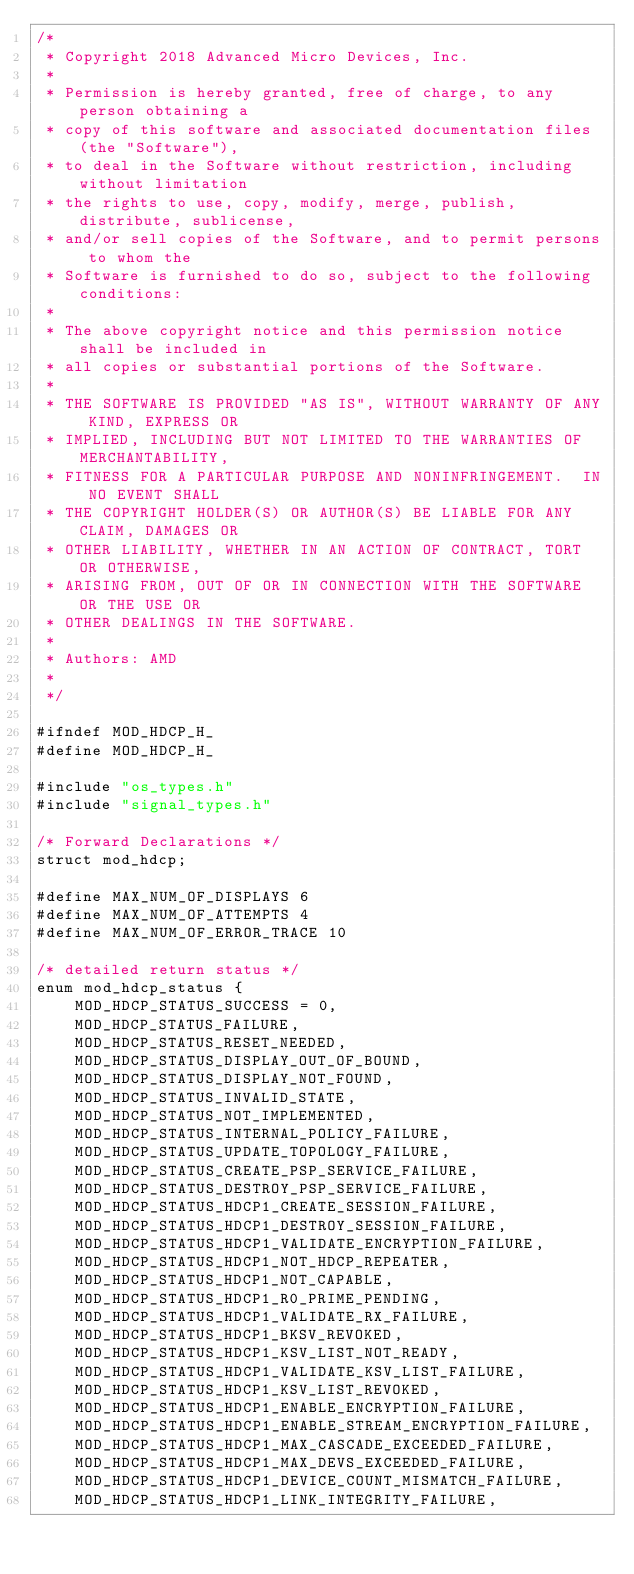Convert code to text. <code><loc_0><loc_0><loc_500><loc_500><_C_>/*
 * Copyright 2018 Advanced Micro Devices, Inc.
 *
 * Permission is hereby granted, free of charge, to any person obtaining a
 * copy of this software and associated documentation files (the "Software"),
 * to deal in the Software without restriction, including without limitation
 * the rights to use, copy, modify, merge, publish, distribute, sublicense,
 * and/or sell copies of the Software, and to permit persons to whom the
 * Software is furnished to do so, subject to the following conditions:
 *
 * The above copyright notice and this permission notice shall be included in
 * all copies or substantial portions of the Software.
 *
 * THE SOFTWARE IS PROVIDED "AS IS", WITHOUT WARRANTY OF ANY KIND, EXPRESS OR
 * IMPLIED, INCLUDING BUT NOT LIMITED TO THE WARRANTIES OF MERCHANTABILITY,
 * FITNESS FOR A PARTICULAR PURPOSE AND NONINFRINGEMENT.  IN NO EVENT SHALL
 * THE COPYRIGHT HOLDER(S) OR AUTHOR(S) BE LIABLE FOR ANY CLAIM, DAMAGES OR
 * OTHER LIABILITY, WHETHER IN AN ACTION OF CONTRACT, TORT OR OTHERWISE,
 * ARISING FROM, OUT OF OR IN CONNECTION WITH THE SOFTWARE OR THE USE OR
 * OTHER DEALINGS IN THE SOFTWARE.
 *
 * Authors: AMD
 *
 */

#ifndef MOD_HDCP_H_
#define MOD_HDCP_H_

#include "os_types.h"
#include "signal_types.h"

/* Forward Declarations */
struct mod_hdcp;

#define MAX_NUM_OF_DISPLAYS 6
#define MAX_NUM_OF_ATTEMPTS 4
#define MAX_NUM_OF_ERROR_TRACE 10

/* detailed return status */
enum mod_hdcp_status {
	MOD_HDCP_STATUS_SUCCESS = 0,
	MOD_HDCP_STATUS_FAILURE,
	MOD_HDCP_STATUS_RESET_NEEDED,
	MOD_HDCP_STATUS_DISPLAY_OUT_OF_BOUND,
	MOD_HDCP_STATUS_DISPLAY_NOT_FOUND,
	MOD_HDCP_STATUS_INVALID_STATE,
	MOD_HDCP_STATUS_NOT_IMPLEMENTED,
	MOD_HDCP_STATUS_INTERNAL_POLICY_FAILURE,
	MOD_HDCP_STATUS_UPDATE_TOPOLOGY_FAILURE,
	MOD_HDCP_STATUS_CREATE_PSP_SERVICE_FAILURE,
	MOD_HDCP_STATUS_DESTROY_PSP_SERVICE_FAILURE,
	MOD_HDCP_STATUS_HDCP1_CREATE_SESSION_FAILURE,
	MOD_HDCP_STATUS_HDCP1_DESTROY_SESSION_FAILURE,
	MOD_HDCP_STATUS_HDCP1_VALIDATE_ENCRYPTION_FAILURE,
	MOD_HDCP_STATUS_HDCP1_NOT_HDCP_REPEATER,
	MOD_HDCP_STATUS_HDCP1_NOT_CAPABLE,
	MOD_HDCP_STATUS_HDCP1_R0_PRIME_PENDING,
	MOD_HDCP_STATUS_HDCP1_VALIDATE_RX_FAILURE,
	MOD_HDCP_STATUS_HDCP1_BKSV_REVOKED,
	MOD_HDCP_STATUS_HDCP1_KSV_LIST_NOT_READY,
	MOD_HDCP_STATUS_HDCP1_VALIDATE_KSV_LIST_FAILURE,
	MOD_HDCP_STATUS_HDCP1_KSV_LIST_REVOKED,
	MOD_HDCP_STATUS_HDCP1_ENABLE_ENCRYPTION_FAILURE,
	MOD_HDCP_STATUS_HDCP1_ENABLE_STREAM_ENCRYPTION_FAILURE,
	MOD_HDCP_STATUS_HDCP1_MAX_CASCADE_EXCEEDED_FAILURE,
	MOD_HDCP_STATUS_HDCP1_MAX_DEVS_EXCEEDED_FAILURE,
	MOD_HDCP_STATUS_HDCP1_DEVICE_COUNT_MISMATCH_FAILURE,
	MOD_HDCP_STATUS_HDCP1_LINK_INTEGRITY_FAILURE,</code> 